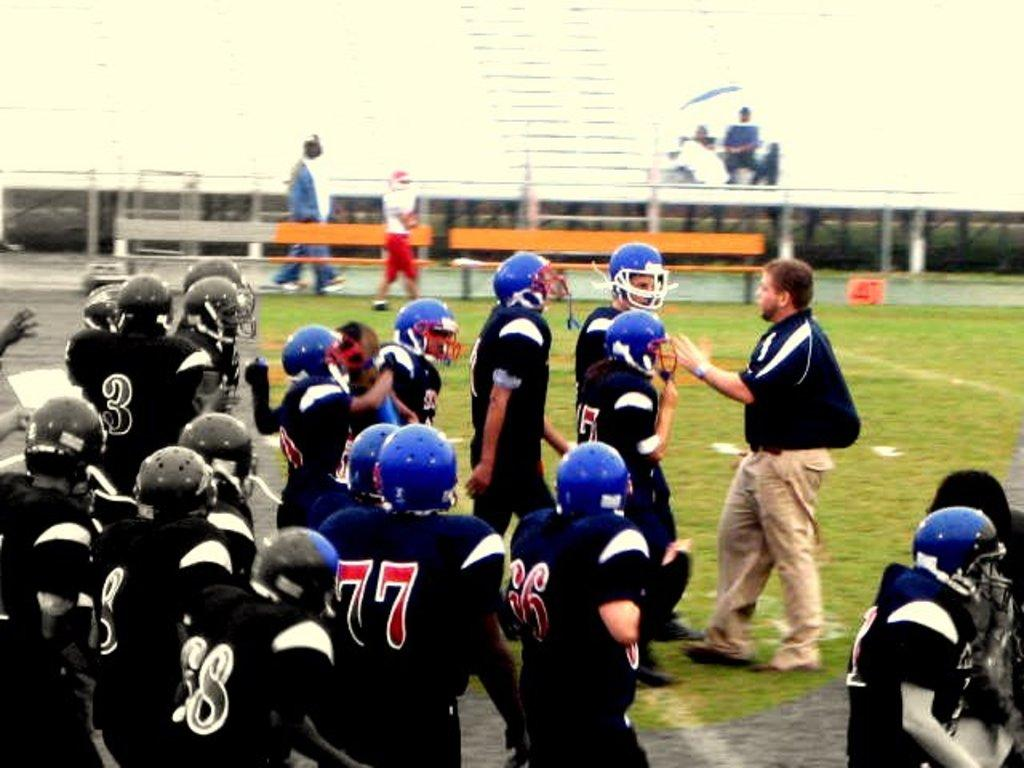What are the people in the image doing? The people in the image are standing in the center. What can be seen in the background of the image? There are benches in the background of the image. What type of surface is at the bottom of the image? There is grass at the bottom of the image. What type of bottle is being used by the authority figure in the image? There is no bottle or authority figure present in the image. What type of tail can be seen on the people in the image? There are no tails visible on the people in the image. 